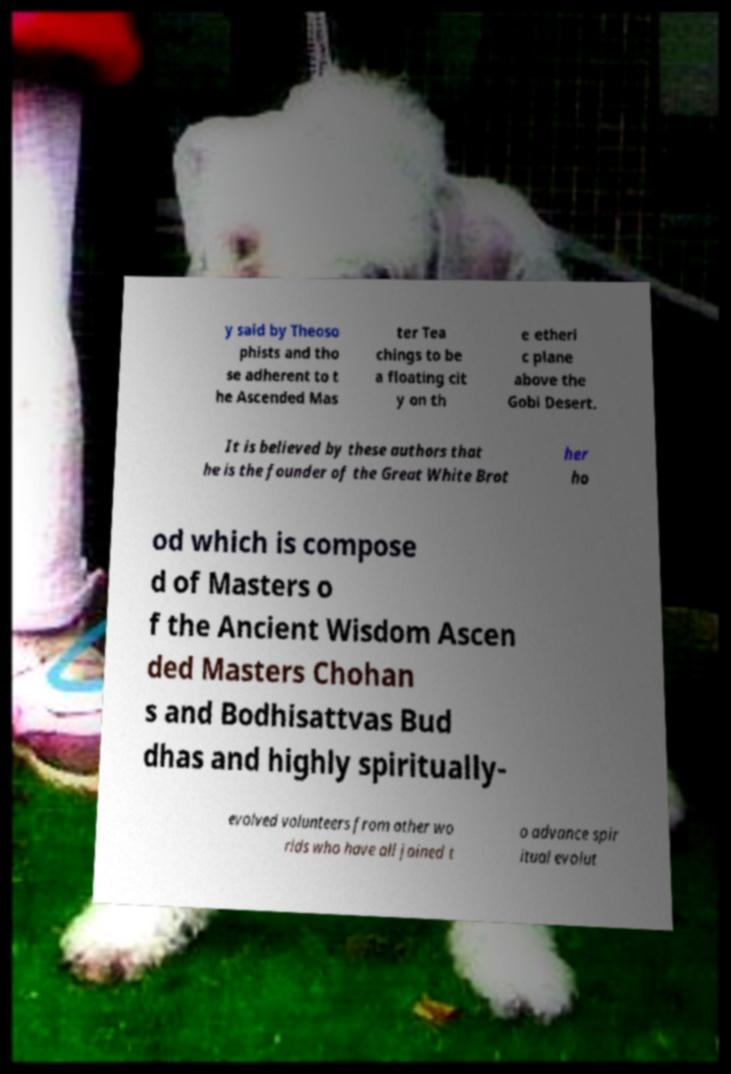Can you read and provide the text displayed in the image?This photo seems to have some interesting text. Can you extract and type it out for me? y said by Theoso phists and tho se adherent to t he Ascended Mas ter Tea chings to be a floating cit y on th e etheri c plane above the Gobi Desert. It is believed by these authors that he is the founder of the Great White Brot her ho od which is compose d of Masters o f the Ancient Wisdom Ascen ded Masters Chohan s and Bodhisattvas Bud dhas and highly spiritually- evolved volunteers from other wo rlds who have all joined t o advance spir itual evolut 